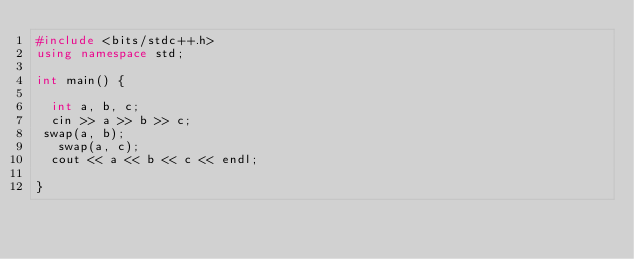<code> <loc_0><loc_0><loc_500><loc_500><_C++_>#include <bits/stdc++.h>
using namespace std;
 
int main() {
 
  int a, b, c;
	cin >> a >> b >> c;
 swap(a, b);
   swap(a, c);
  cout << a << b << c << endl;
 
}</code> 